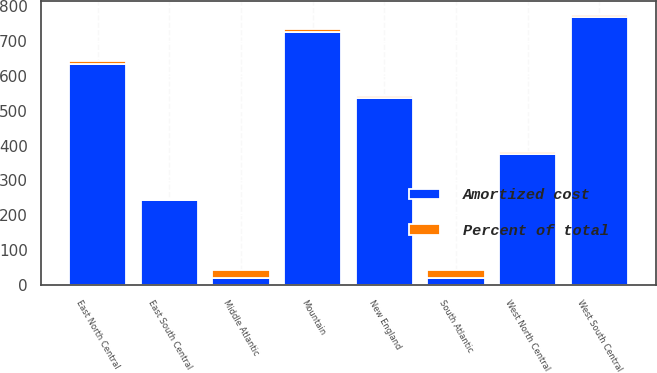Convert chart. <chart><loc_0><loc_0><loc_500><loc_500><stacked_bar_chart><ecel><fcel>New England<fcel>Middle Atlantic<fcel>East North Central<fcel>West North Central<fcel>South Atlantic<fcel>East South Central<fcel>West South Central<fcel>Mountain<nl><fcel>Amortized cost<fcel>536.6<fcel>21.35<fcel>635.6<fcel>377.3<fcel>21.35<fcel>244.8<fcel>767.9<fcel>726.6<nl><fcel>Percent of total<fcel>5.2<fcel>21.8<fcel>6.2<fcel>3.7<fcel>20.9<fcel>2.4<fcel>7.5<fcel>7.1<nl></chart> 